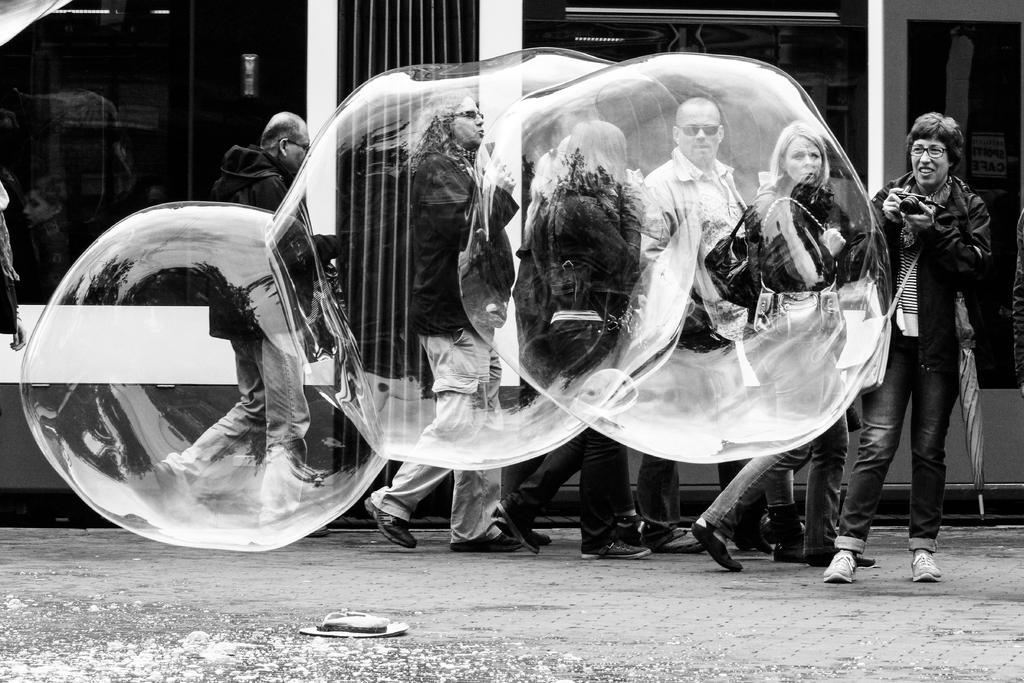Could you give a brief overview of what you see in this image? In this image I can see the black and white picture in which I can see huge water bubbles in the air. I can see few persons are standing on the ground and one of them is holding a camera in hand. In the background I can see a building. 